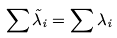<formula> <loc_0><loc_0><loc_500><loc_500>\sum \tilde { \lambda } _ { i } = \sum \lambda _ { i }</formula> 